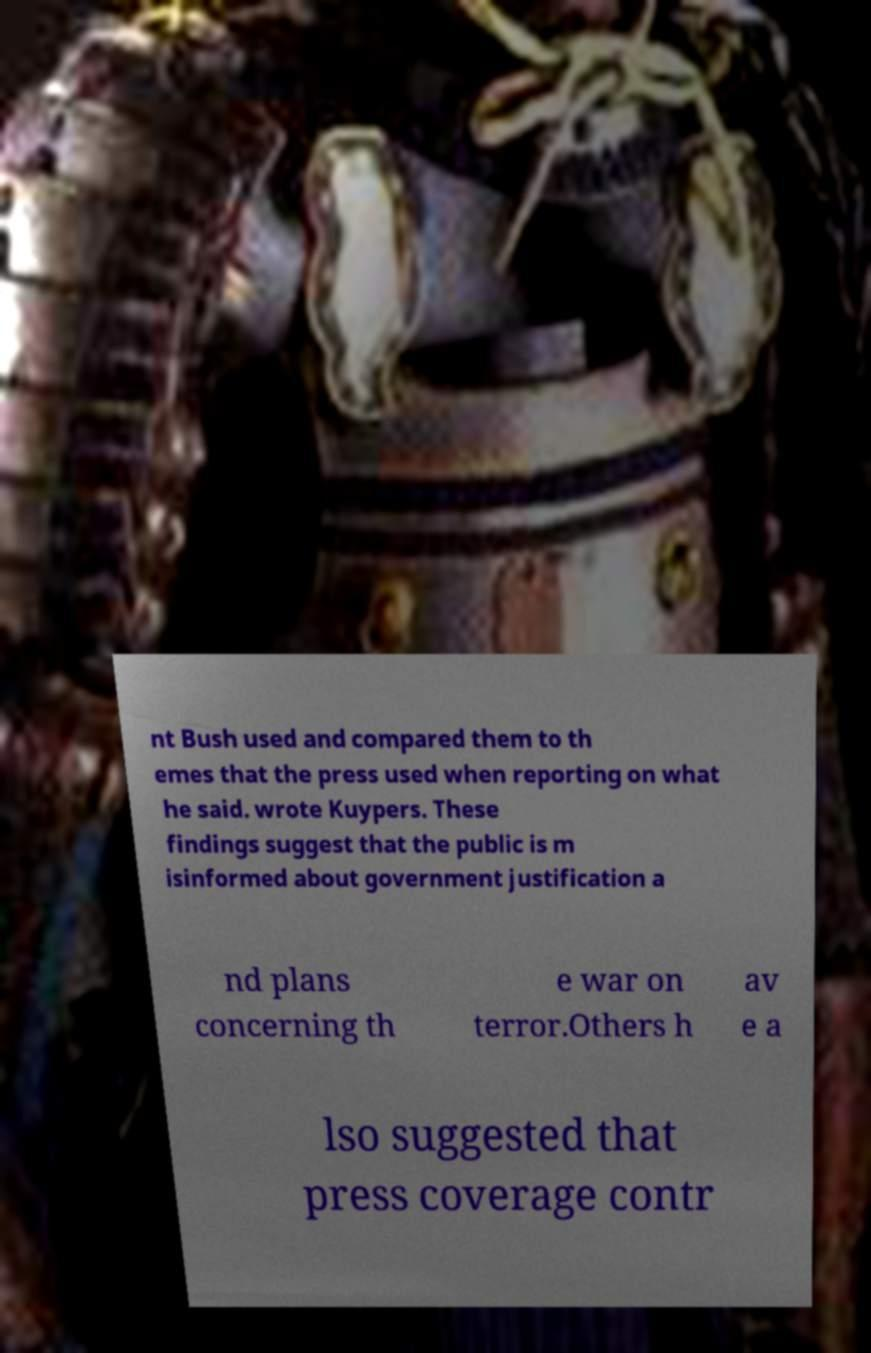What messages or text are displayed in this image? I need them in a readable, typed format. nt Bush used and compared them to th emes that the press used when reporting on what he said. wrote Kuypers. These findings suggest that the public is m isinformed about government justification a nd plans concerning th e war on terror.Others h av e a lso suggested that press coverage contr 